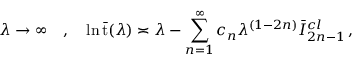Convert formula to latex. <formula><loc_0><loc_0><loc_500><loc_500>\lambda \rightarrow \infty \quad , \quad \ln \bar { t } ( \lambda ) \asymp \lambda - \sum _ { n = 1 } ^ { \infty } c _ { n } \lambda ^ { ( 1 - 2 n ) } \bar { I } _ { 2 n - 1 } ^ { c l } \, ,</formula> 